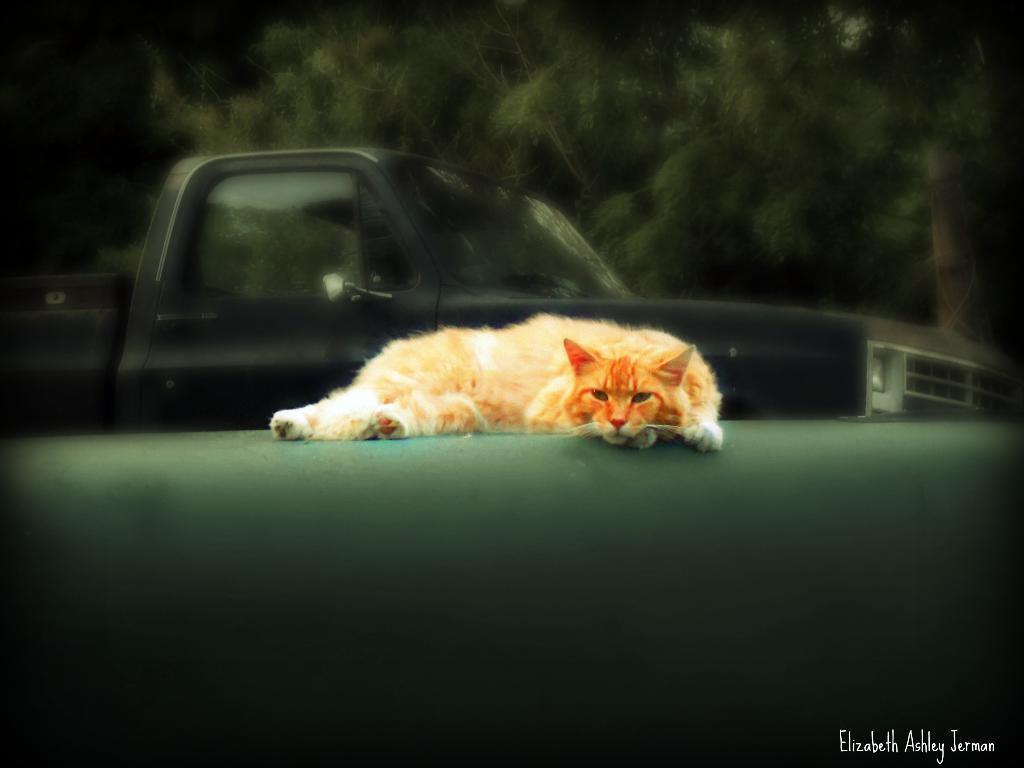How would you summarize this image in a sentence or two? In this image we can see a cat and in the background there is a truck and few trees. 